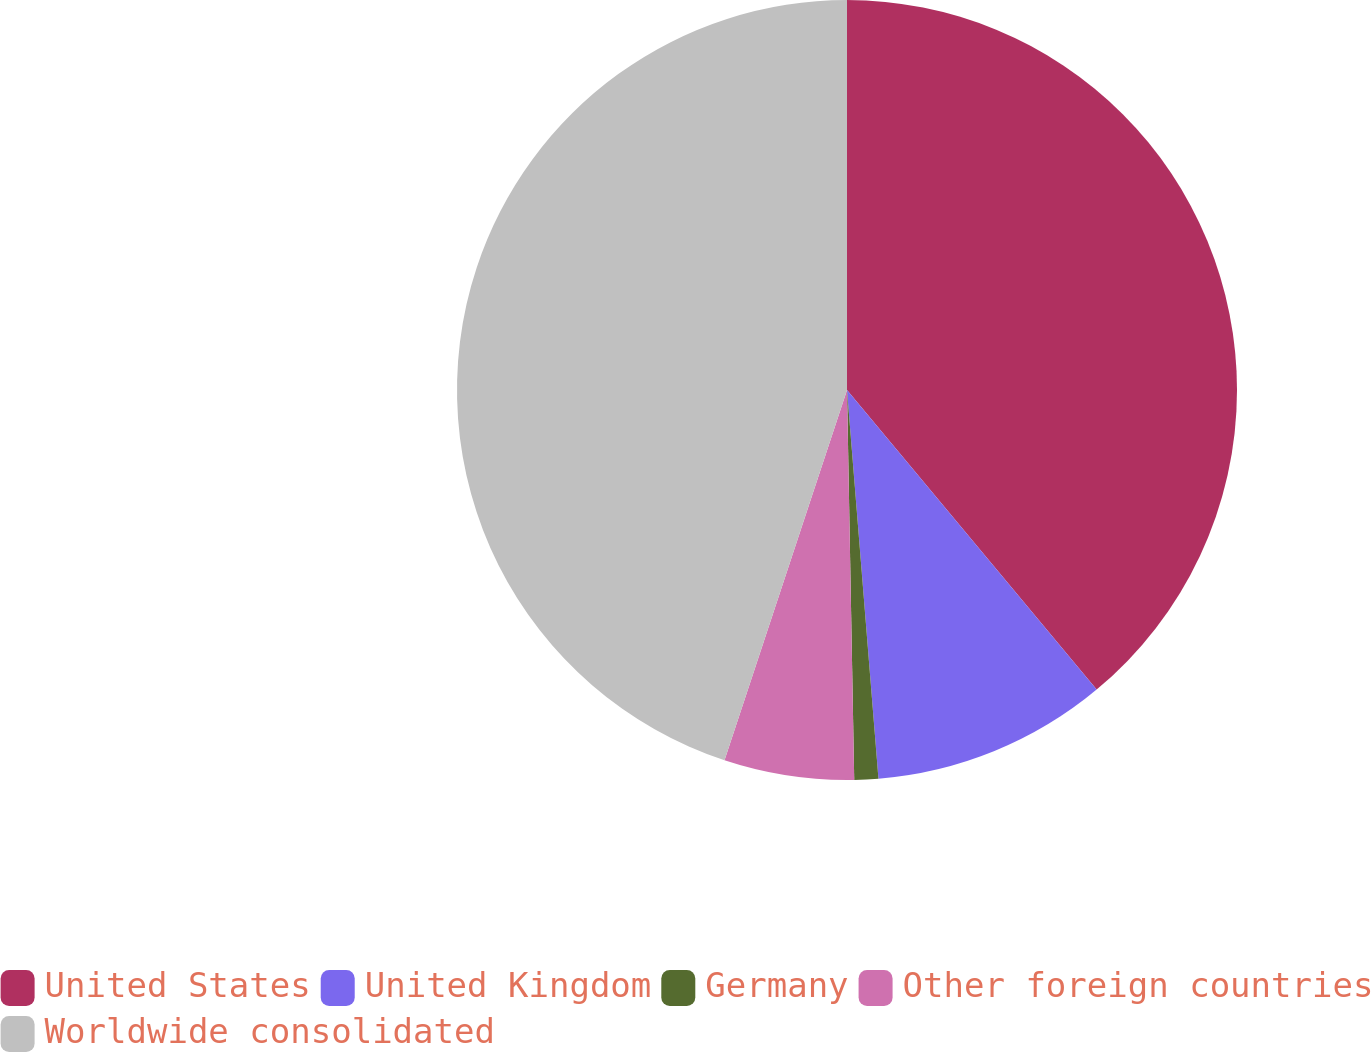Convert chart. <chart><loc_0><loc_0><loc_500><loc_500><pie_chart><fcel>United States<fcel>United Kingdom<fcel>Germany<fcel>Other foreign countries<fcel>Worldwide consolidated<nl><fcel>38.94%<fcel>9.77%<fcel>0.99%<fcel>5.38%<fcel>44.91%<nl></chart> 